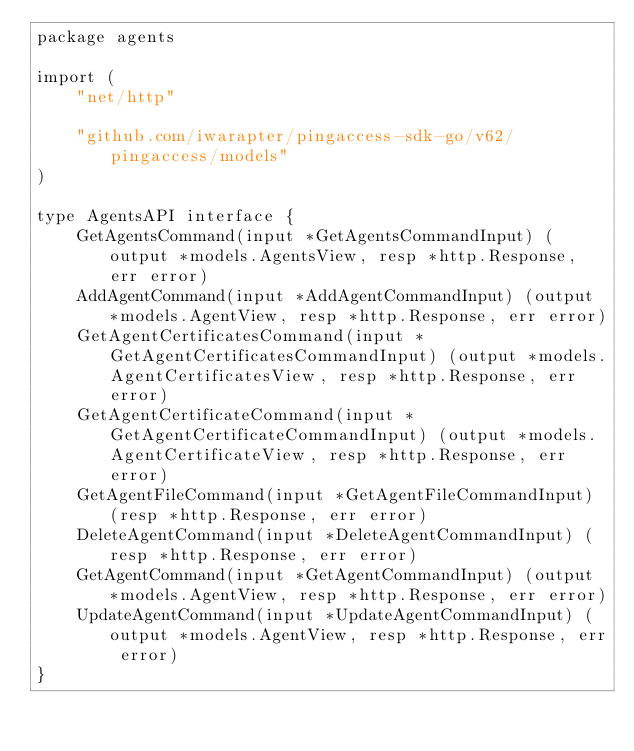Convert code to text. <code><loc_0><loc_0><loc_500><loc_500><_Go_>package agents

import (
	"net/http"

	"github.com/iwarapter/pingaccess-sdk-go/v62/pingaccess/models"
)

type AgentsAPI interface {
	GetAgentsCommand(input *GetAgentsCommandInput) (output *models.AgentsView, resp *http.Response, err error)
	AddAgentCommand(input *AddAgentCommandInput) (output *models.AgentView, resp *http.Response, err error)
	GetAgentCertificatesCommand(input *GetAgentCertificatesCommandInput) (output *models.AgentCertificatesView, resp *http.Response, err error)
	GetAgentCertificateCommand(input *GetAgentCertificateCommandInput) (output *models.AgentCertificateView, resp *http.Response, err error)
	GetAgentFileCommand(input *GetAgentFileCommandInput) (resp *http.Response, err error)
	DeleteAgentCommand(input *DeleteAgentCommandInput) (resp *http.Response, err error)
	GetAgentCommand(input *GetAgentCommandInput) (output *models.AgentView, resp *http.Response, err error)
	UpdateAgentCommand(input *UpdateAgentCommandInput) (output *models.AgentView, resp *http.Response, err error)
}
</code> 